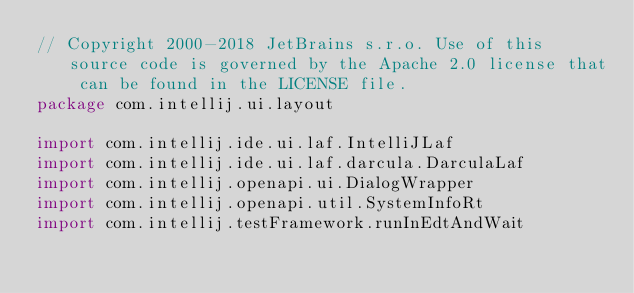Convert code to text. <code><loc_0><loc_0><loc_500><loc_500><_Kotlin_>// Copyright 2000-2018 JetBrains s.r.o. Use of this source code is governed by the Apache 2.0 license that can be found in the LICENSE file.
package com.intellij.ui.layout

import com.intellij.ide.ui.laf.IntelliJLaf
import com.intellij.ide.ui.laf.darcula.DarculaLaf
import com.intellij.openapi.ui.DialogWrapper
import com.intellij.openapi.util.SystemInfoRt
import com.intellij.testFramework.runInEdtAndWait</code> 